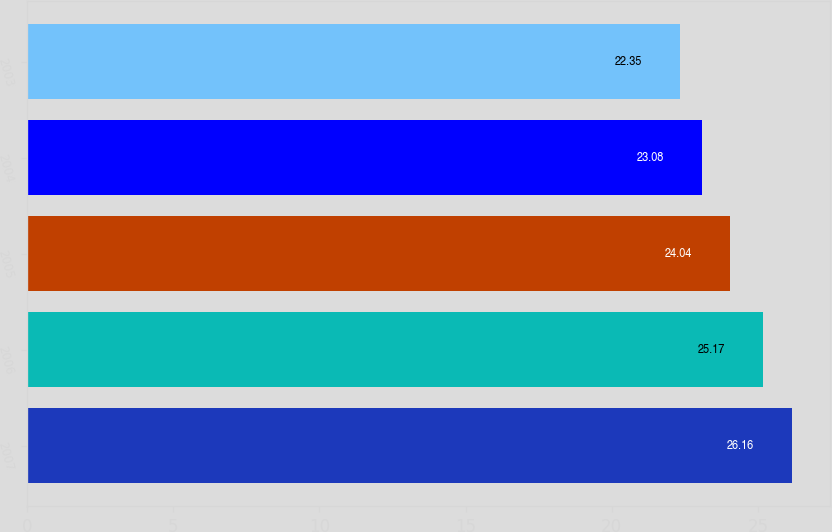Convert chart. <chart><loc_0><loc_0><loc_500><loc_500><bar_chart><fcel>2007<fcel>2006<fcel>2005<fcel>2004<fcel>2003<nl><fcel>26.16<fcel>25.17<fcel>24.04<fcel>23.08<fcel>22.35<nl></chart> 